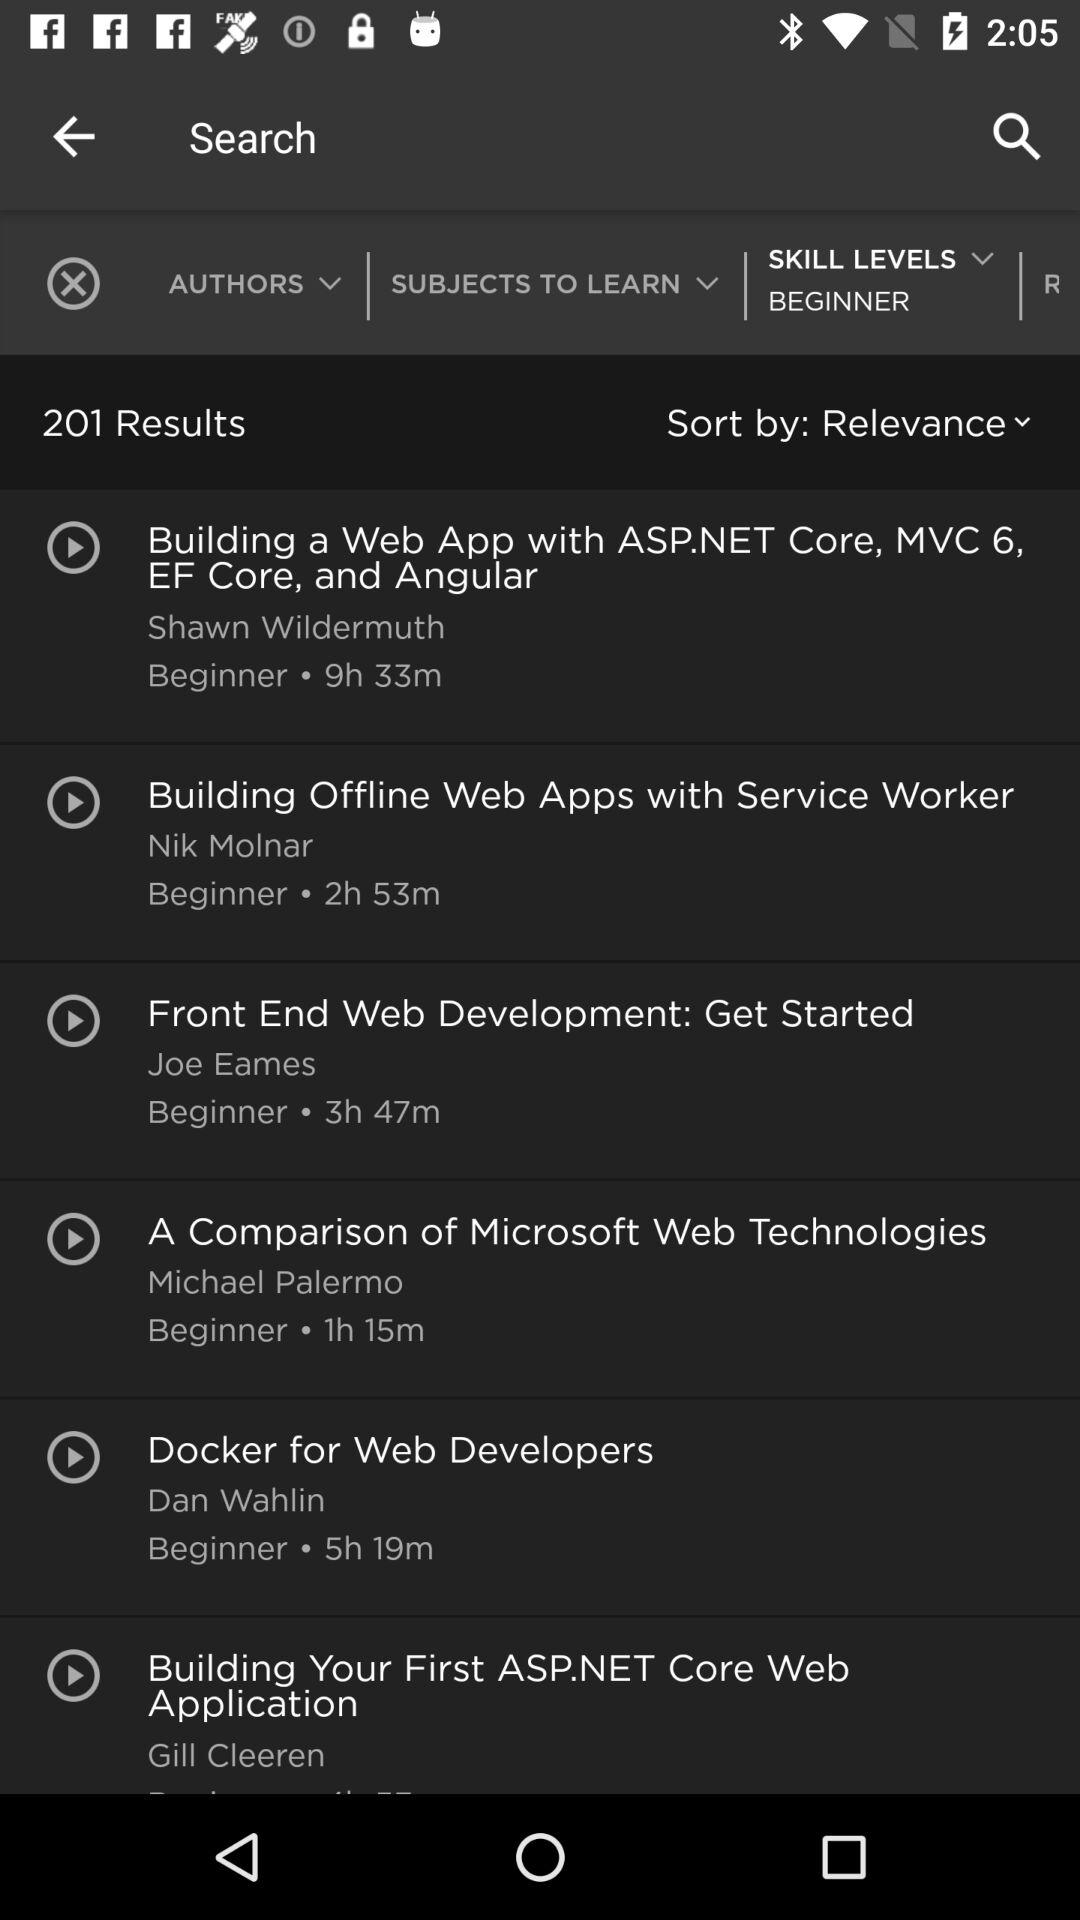How many results are shown on the screen? There are 201 results shown on the screen. 